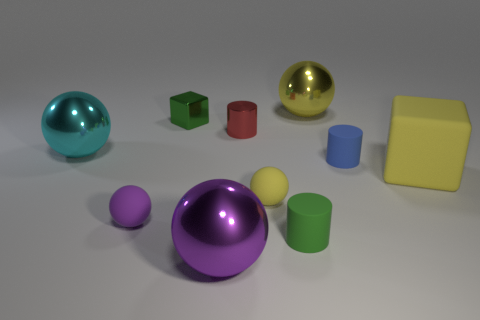Does the tiny block have the same color as the rubber cylinder behind the purple matte object?
Your answer should be very brief. No. What is the shape of the tiny red thing?
Ensure brevity in your answer.  Cylinder. What color is the big shiny sphere in front of the large cyan metal sphere?
Ensure brevity in your answer.  Purple. Do the big purple ball and the tiny yellow object have the same material?
Your answer should be very brief. No. How many objects are either big cyan shiny objects or large things that are to the right of the metallic cube?
Your answer should be compact. 4. What size is the thing that is the same color as the metallic block?
Your response must be concise. Small. There is a metallic object behind the metallic block; what is its shape?
Your answer should be compact. Sphere. There is a matte thing left of the red shiny thing; does it have the same color as the small shiny block?
Give a very brief answer. No. What is the material of the cylinder that is the same color as the small cube?
Provide a succinct answer. Rubber. Do the shiny sphere on the left side of the green block and the large purple shiny ball have the same size?
Your response must be concise. Yes. 